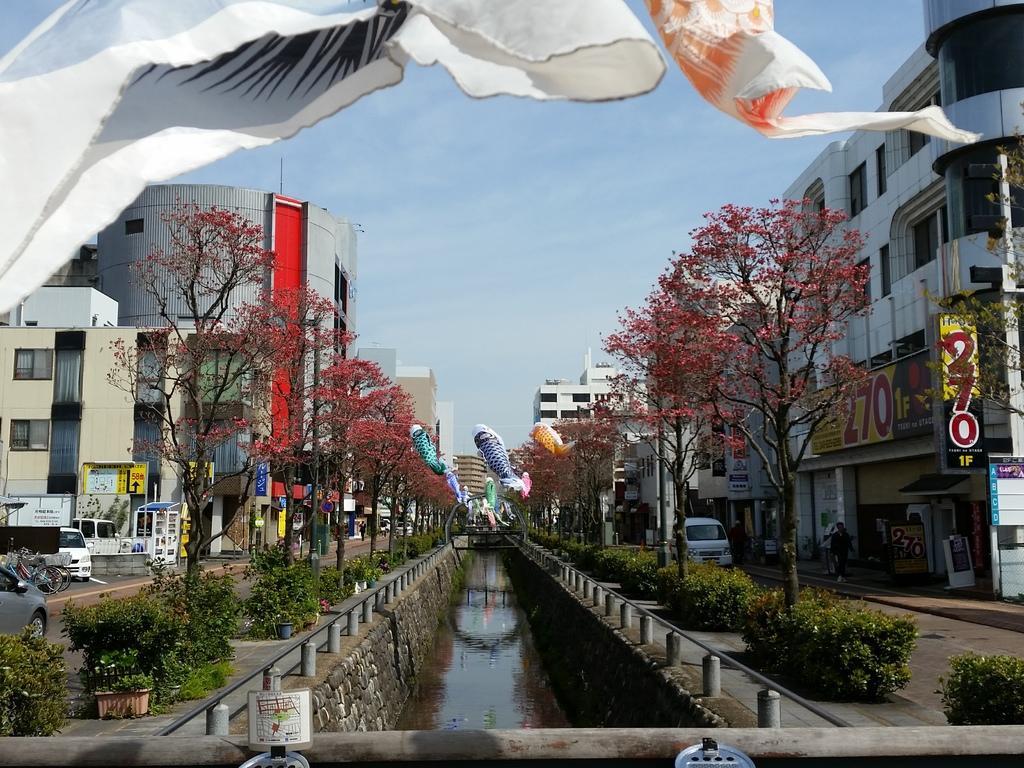Could you give a brief overview of what you see in this image? In this image at the bottom, there are plants, water, bridge, poster, cars. In the middle there are air balloons, cars, road, trees, buildings, posters, text, sky and clouds. At the top there are clothes. 